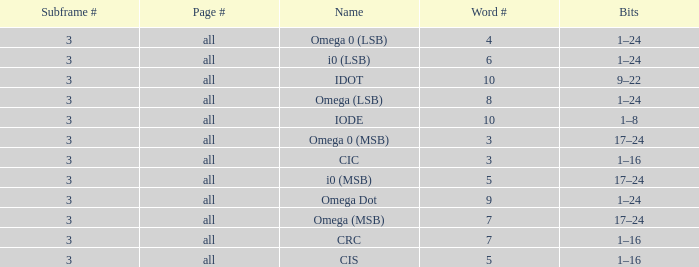What is the total word count with a subframe count greater than 3? None. 